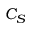Convert formula to latex. <formula><loc_0><loc_0><loc_500><loc_500>C _ { S }</formula> 